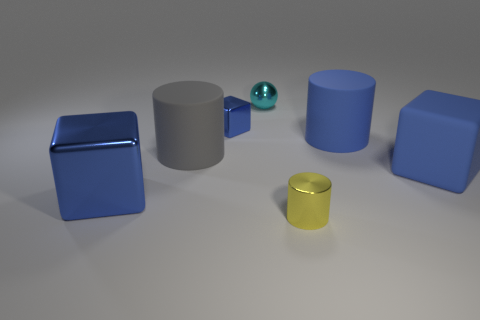How many blue blocks must be subtracted to get 1 blue blocks? 2 Add 2 big gray spheres. How many objects exist? 9 Subtract all balls. How many objects are left? 6 Add 5 cyan metallic cylinders. How many cyan metallic cylinders exist? 5 Subtract 0 purple blocks. How many objects are left? 7 Subtract all brown rubber cylinders. Subtract all cyan metallic things. How many objects are left? 6 Add 3 cyan spheres. How many cyan spheres are left? 4 